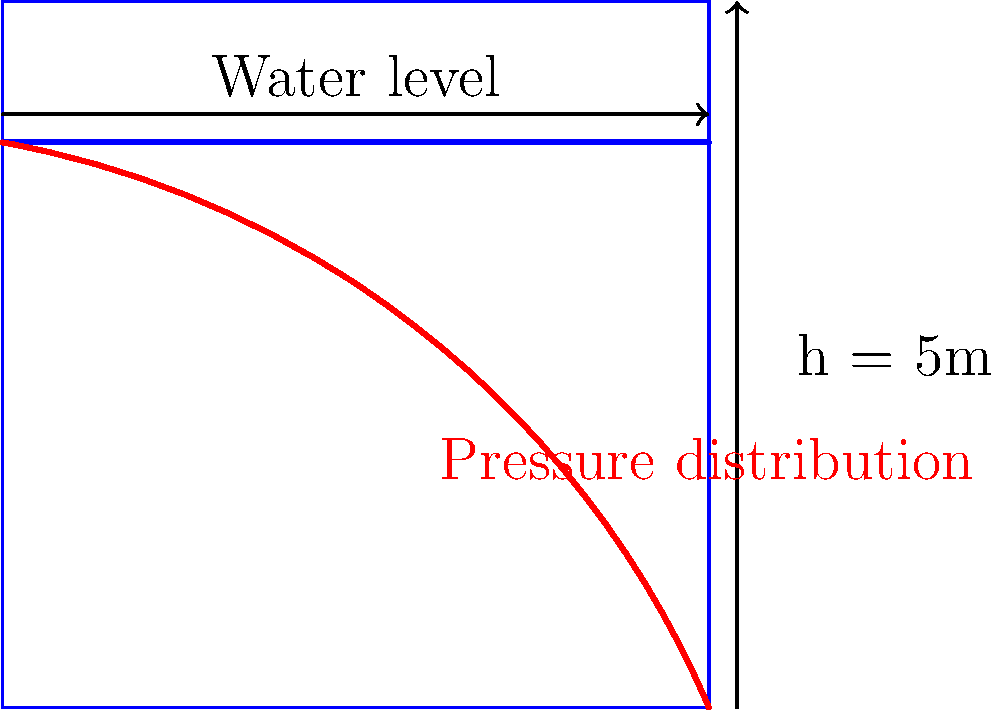As a tech-savvy Dutch student always on the move, you're tasked with quickly estimating the water pressure distribution on a dam wall. Given a dam height of 5 meters and a water level at 4 meters, what is the maximum water pressure at the base of the dam? Assume the density of water is 1000 kg/m³ and acceleration due to gravity is 9.81 m/s². To calculate the maximum water pressure at the base of the dam, we'll follow these steps:

1. Identify the relevant formula:
   The pressure at depth h in a fluid is given by $$P = \rho g h$$
   where:
   $P$ is pressure (Pa)
   $\rho$ is fluid density (kg/m³)
   $g$ is acceleration due to gravity (m/s²)
   $h$ is depth (m)

2. Input the given values:
   $\rho = 1000$ kg/m³
   $g = 9.81$ m/s²
   $h = 4$ m (depth at the base, equal to the water level)

3. Calculate the pressure:
   $$P = 1000 \times 9.81 \times 4 = 39,240 \text{ Pa}$$

4. Convert to a more commonly used unit:
   $$39,240 \text{ Pa} = 39.24 \text{ kPa}$$

The pressure distribution will be triangular, with zero pressure at the water surface and maximum pressure at the base.
Answer: 39.24 kPa 